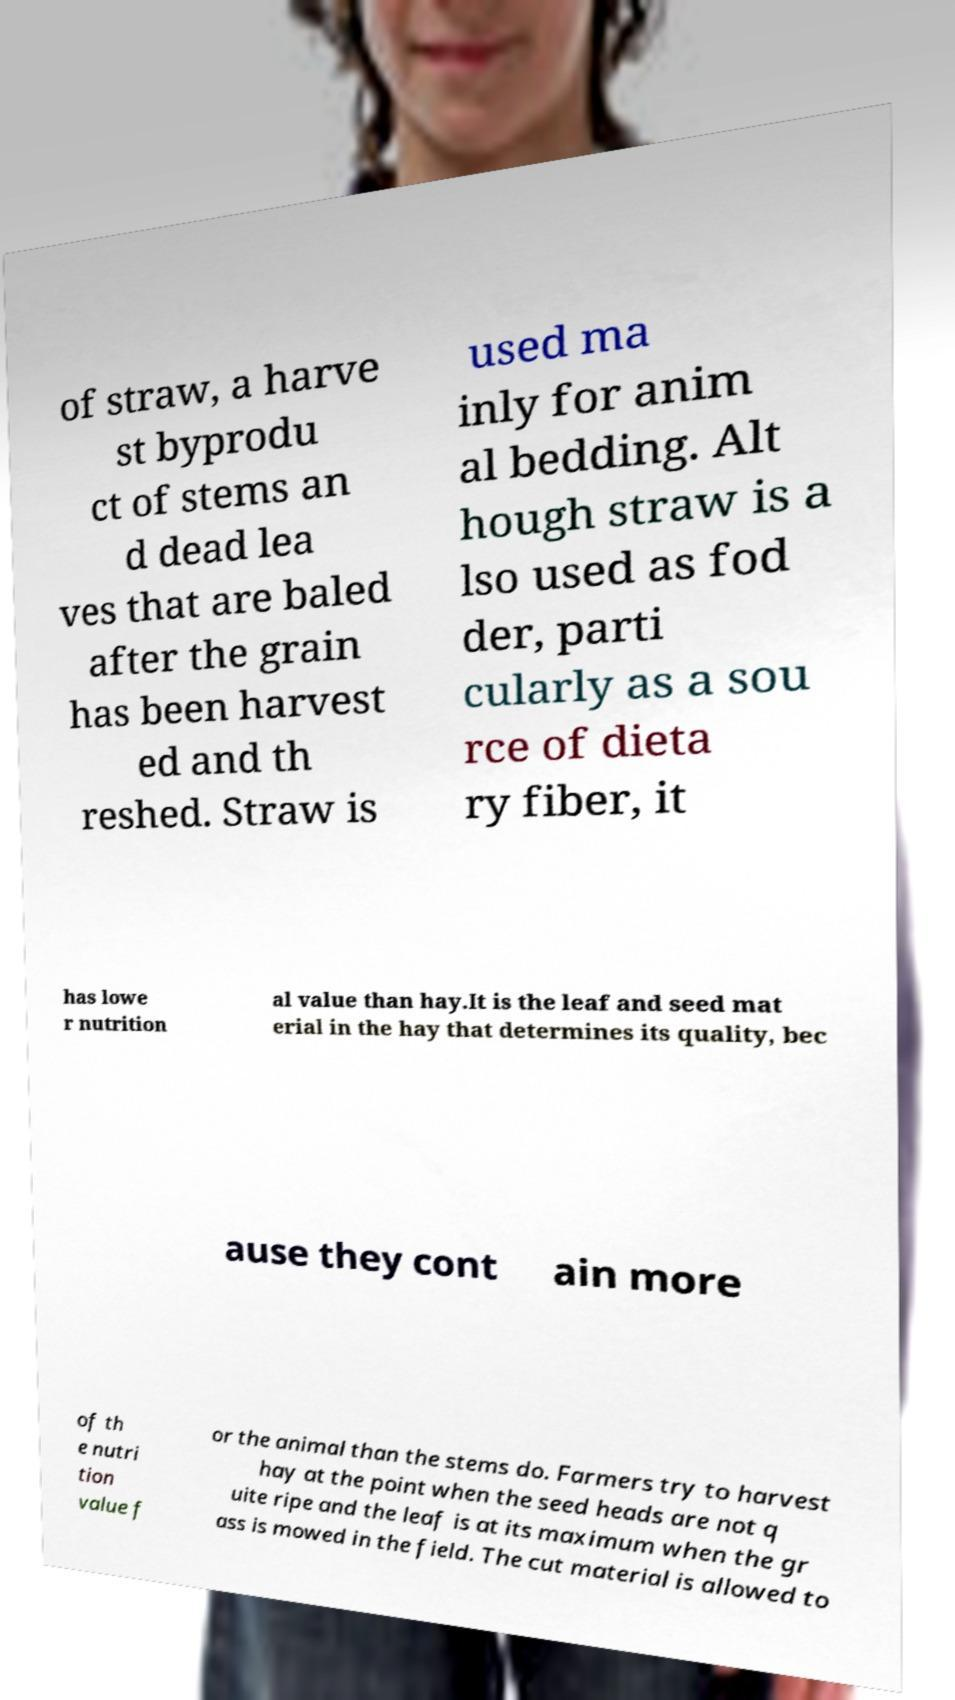What messages or text are displayed in this image? I need them in a readable, typed format. of straw, a harve st byprodu ct of stems an d dead lea ves that are baled after the grain has been harvest ed and th reshed. Straw is used ma inly for anim al bedding. Alt hough straw is a lso used as fod der, parti cularly as a sou rce of dieta ry fiber, it has lowe r nutrition al value than hay.It is the leaf and seed mat erial in the hay that determines its quality, bec ause they cont ain more of th e nutri tion value f or the animal than the stems do. Farmers try to harvest hay at the point when the seed heads are not q uite ripe and the leaf is at its maximum when the gr ass is mowed in the field. The cut material is allowed to 